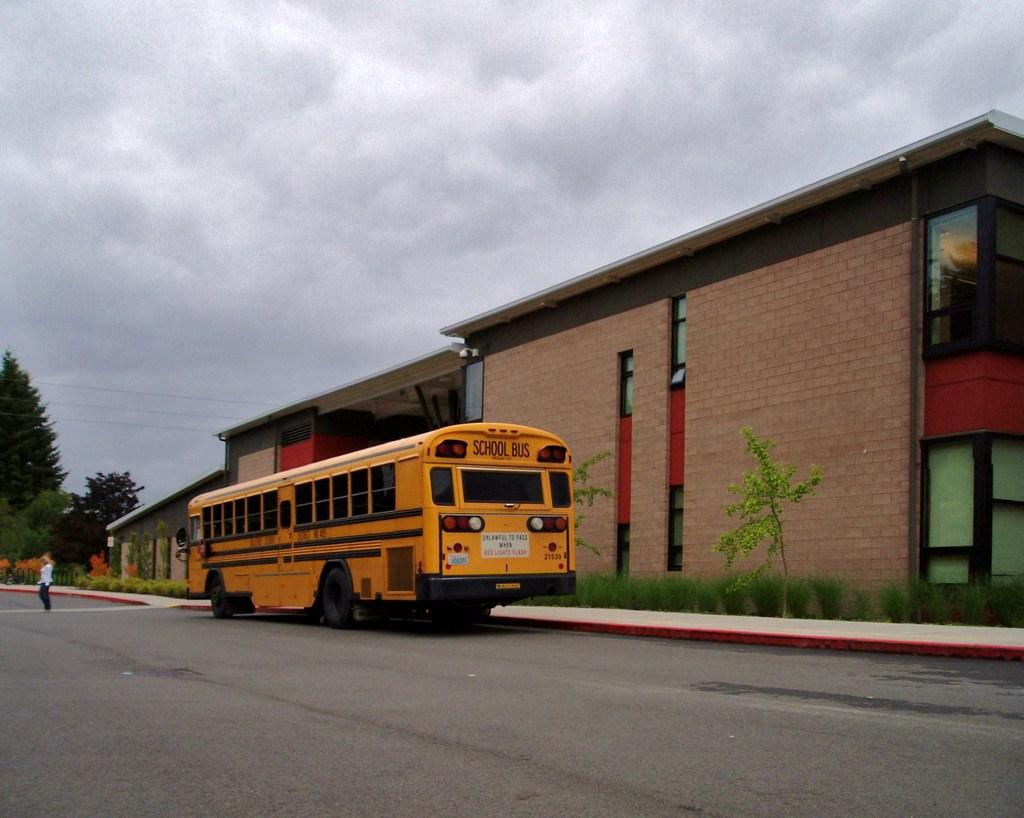What is on the road in the image? There is a vehicle on the road in the image. Can you describe the person in the image? There is a person wearing clothes in the image. What structures can be seen in the image? There are buildings visible in the image. What type of vegetation is present in the image? Trees and plants are present in the image. What else can be seen in the sky besides clouds? The sky is cloudy in the image, so there are no other visible features besides the clouds. What type of tub is visible in the image? There is no tub present in the image. What is the make and model of the engine in the image? There is no engine present in the image, as it is a vehicle on the road, not a vehicle being disassembled. 